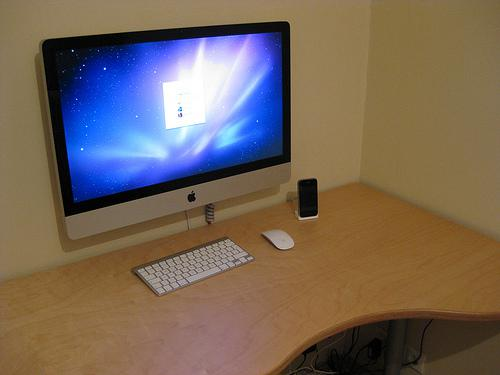Question: where is the keyboard?
Choices:
A. On the rack.
B. On the floor.
C. On the computer desk.
D. On the table.
Answer with the letter. Answer: D Question: what is on the wall?
Choices:
A. The picture.
B. A monitor.
C. The clock.
D. The plant.
Answer with the letter. Answer: B Question: who is using the computer?
Choices:
A. No one.
B. My daughter.
C. The little boy.
D. The tall man.
Answer with the letter. Answer: A Question: when was the mac set up?
Choices:
A. Last night.
B. This morning.
C. Yesterday.
D. Earlier.
Answer with the letter. Answer: D Question: why the monitor hanging on the wall?
Choices:
A. You can move it around.
B. It's on display.
C. It's more accessible.
D. The security officer views the building.
Answer with the letter. Answer: C 